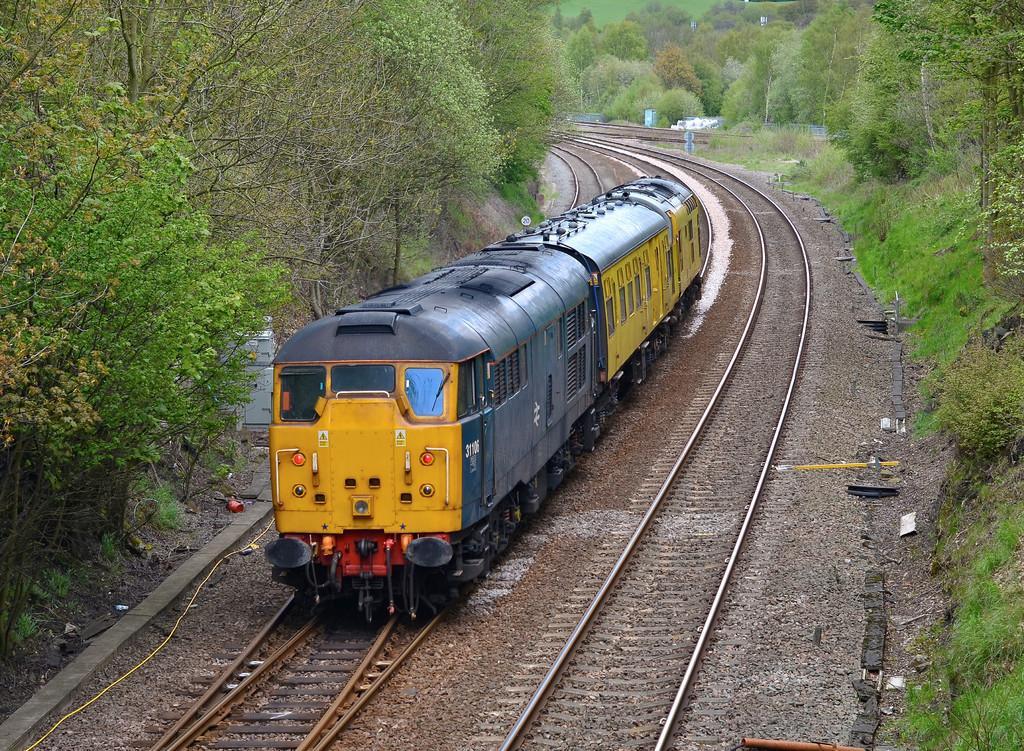Please provide a concise description of this image. In this image we can see a train on the track. We can also see some stones, trees and grass. 